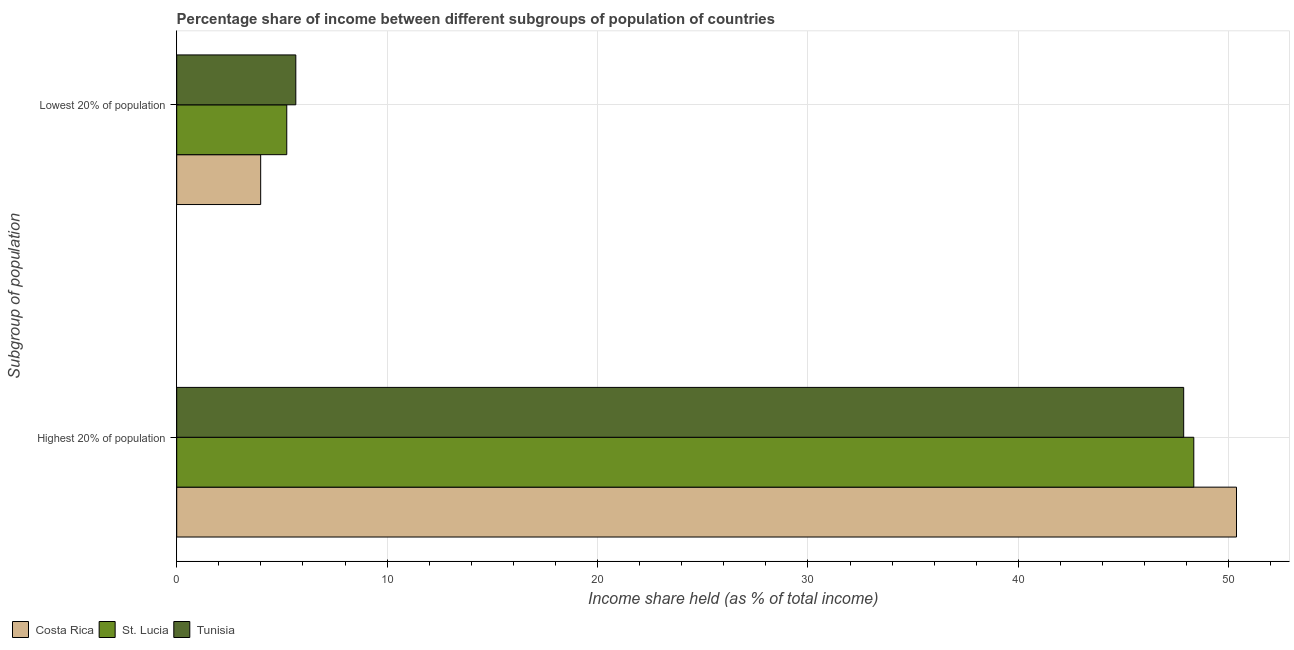How many different coloured bars are there?
Make the answer very short. 3. Are the number of bars per tick equal to the number of legend labels?
Offer a very short reply. Yes. Are the number of bars on each tick of the Y-axis equal?
Offer a very short reply. Yes. How many bars are there on the 2nd tick from the bottom?
Make the answer very short. 3. What is the label of the 2nd group of bars from the top?
Make the answer very short. Highest 20% of population. What is the income share held by lowest 20% of the population in St. Lucia?
Provide a succinct answer. 5.23. Across all countries, what is the maximum income share held by lowest 20% of the population?
Give a very brief answer. 5.66. Across all countries, what is the minimum income share held by highest 20% of the population?
Give a very brief answer. 47.86. In which country was the income share held by lowest 20% of the population maximum?
Give a very brief answer. Tunisia. In which country was the income share held by highest 20% of the population minimum?
Provide a short and direct response. Tunisia. What is the total income share held by lowest 20% of the population in the graph?
Your answer should be compact. 14.88. What is the difference between the income share held by lowest 20% of the population in Costa Rica and that in St. Lucia?
Keep it short and to the point. -1.24. What is the difference between the income share held by lowest 20% of the population in St. Lucia and the income share held by highest 20% of the population in Tunisia?
Your answer should be very brief. -42.63. What is the average income share held by highest 20% of the population per country?
Offer a terse response. 48.86. What is the difference between the income share held by lowest 20% of the population and income share held by highest 20% of the population in Costa Rica?
Your answer should be compact. -46.38. What is the ratio of the income share held by lowest 20% of the population in Costa Rica to that in St. Lucia?
Ensure brevity in your answer.  0.76. Is the income share held by lowest 20% of the population in Tunisia less than that in Costa Rica?
Keep it short and to the point. No. In how many countries, is the income share held by lowest 20% of the population greater than the average income share held by lowest 20% of the population taken over all countries?
Keep it short and to the point. 2. What does the 1st bar from the top in Highest 20% of population represents?
Your answer should be very brief. Tunisia. What does the 3rd bar from the bottom in Lowest 20% of population represents?
Your answer should be compact. Tunisia. How many bars are there?
Your answer should be very brief. 6. How many countries are there in the graph?
Offer a terse response. 3. What is the difference between two consecutive major ticks on the X-axis?
Keep it short and to the point. 10. Does the graph contain grids?
Ensure brevity in your answer.  Yes. Where does the legend appear in the graph?
Make the answer very short. Bottom left. How many legend labels are there?
Offer a very short reply. 3. How are the legend labels stacked?
Make the answer very short. Horizontal. What is the title of the graph?
Keep it short and to the point. Percentage share of income between different subgroups of population of countries. Does "Lesotho" appear as one of the legend labels in the graph?
Provide a succinct answer. No. What is the label or title of the X-axis?
Provide a succinct answer. Income share held (as % of total income). What is the label or title of the Y-axis?
Keep it short and to the point. Subgroup of population. What is the Income share held (as % of total income) in Costa Rica in Highest 20% of population?
Your response must be concise. 50.37. What is the Income share held (as % of total income) of St. Lucia in Highest 20% of population?
Make the answer very short. 48.34. What is the Income share held (as % of total income) of Tunisia in Highest 20% of population?
Offer a terse response. 47.86. What is the Income share held (as % of total income) in Costa Rica in Lowest 20% of population?
Your response must be concise. 3.99. What is the Income share held (as % of total income) of St. Lucia in Lowest 20% of population?
Your answer should be very brief. 5.23. What is the Income share held (as % of total income) of Tunisia in Lowest 20% of population?
Your answer should be compact. 5.66. Across all Subgroup of population, what is the maximum Income share held (as % of total income) of Costa Rica?
Your answer should be very brief. 50.37. Across all Subgroup of population, what is the maximum Income share held (as % of total income) in St. Lucia?
Your response must be concise. 48.34. Across all Subgroup of population, what is the maximum Income share held (as % of total income) in Tunisia?
Give a very brief answer. 47.86. Across all Subgroup of population, what is the minimum Income share held (as % of total income) of Costa Rica?
Give a very brief answer. 3.99. Across all Subgroup of population, what is the minimum Income share held (as % of total income) in St. Lucia?
Offer a very short reply. 5.23. Across all Subgroup of population, what is the minimum Income share held (as % of total income) in Tunisia?
Your answer should be very brief. 5.66. What is the total Income share held (as % of total income) in Costa Rica in the graph?
Provide a succinct answer. 54.36. What is the total Income share held (as % of total income) of St. Lucia in the graph?
Make the answer very short. 53.57. What is the total Income share held (as % of total income) in Tunisia in the graph?
Keep it short and to the point. 53.52. What is the difference between the Income share held (as % of total income) of Costa Rica in Highest 20% of population and that in Lowest 20% of population?
Make the answer very short. 46.38. What is the difference between the Income share held (as % of total income) in St. Lucia in Highest 20% of population and that in Lowest 20% of population?
Provide a short and direct response. 43.11. What is the difference between the Income share held (as % of total income) of Tunisia in Highest 20% of population and that in Lowest 20% of population?
Your answer should be compact. 42.2. What is the difference between the Income share held (as % of total income) in Costa Rica in Highest 20% of population and the Income share held (as % of total income) in St. Lucia in Lowest 20% of population?
Your response must be concise. 45.14. What is the difference between the Income share held (as % of total income) of Costa Rica in Highest 20% of population and the Income share held (as % of total income) of Tunisia in Lowest 20% of population?
Provide a short and direct response. 44.71. What is the difference between the Income share held (as % of total income) of St. Lucia in Highest 20% of population and the Income share held (as % of total income) of Tunisia in Lowest 20% of population?
Your answer should be compact. 42.68. What is the average Income share held (as % of total income) in Costa Rica per Subgroup of population?
Provide a succinct answer. 27.18. What is the average Income share held (as % of total income) of St. Lucia per Subgroup of population?
Give a very brief answer. 26.79. What is the average Income share held (as % of total income) in Tunisia per Subgroup of population?
Offer a terse response. 26.76. What is the difference between the Income share held (as % of total income) in Costa Rica and Income share held (as % of total income) in St. Lucia in Highest 20% of population?
Offer a terse response. 2.03. What is the difference between the Income share held (as % of total income) in Costa Rica and Income share held (as % of total income) in Tunisia in Highest 20% of population?
Offer a very short reply. 2.51. What is the difference between the Income share held (as % of total income) of St. Lucia and Income share held (as % of total income) of Tunisia in Highest 20% of population?
Give a very brief answer. 0.48. What is the difference between the Income share held (as % of total income) of Costa Rica and Income share held (as % of total income) of St. Lucia in Lowest 20% of population?
Your response must be concise. -1.24. What is the difference between the Income share held (as % of total income) of Costa Rica and Income share held (as % of total income) of Tunisia in Lowest 20% of population?
Make the answer very short. -1.67. What is the difference between the Income share held (as % of total income) of St. Lucia and Income share held (as % of total income) of Tunisia in Lowest 20% of population?
Provide a succinct answer. -0.43. What is the ratio of the Income share held (as % of total income) of Costa Rica in Highest 20% of population to that in Lowest 20% of population?
Your answer should be very brief. 12.62. What is the ratio of the Income share held (as % of total income) of St. Lucia in Highest 20% of population to that in Lowest 20% of population?
Make the answer very short. 9.24. What is the ratio of the Income share held (as % of total income) of Tunisia in Highest 20% of population to that in Lowest 20% of population?
Provide a short and direct response. 8.46. What is the difference between the highest and the second highest Income share held (as % of total income) of Costa Rica?
Your response must be concise. 46.38. What is the difference between the highest and the second highest Income share held (as % of total income) in St. Lucia?
Offer a very short reply. 43.11. What is the difference between the highest and the second highest Income share held (as % of total income) in Tunisia?
Your answer should be compact. 42.2. What is the difference between the highest and the lowest Income share held (as % of total income) in Costa Rica?
Give a very brief answer. 46.38. What is the difference between the highest and the lowest Income share held (as % of total income) in St. Lucia?
Give a very brief answer. 43.11. What is the difference between the highest and the lowest Income share held (as % of total income) in Tunisia?
Your answer should be very brief. 42.2. 